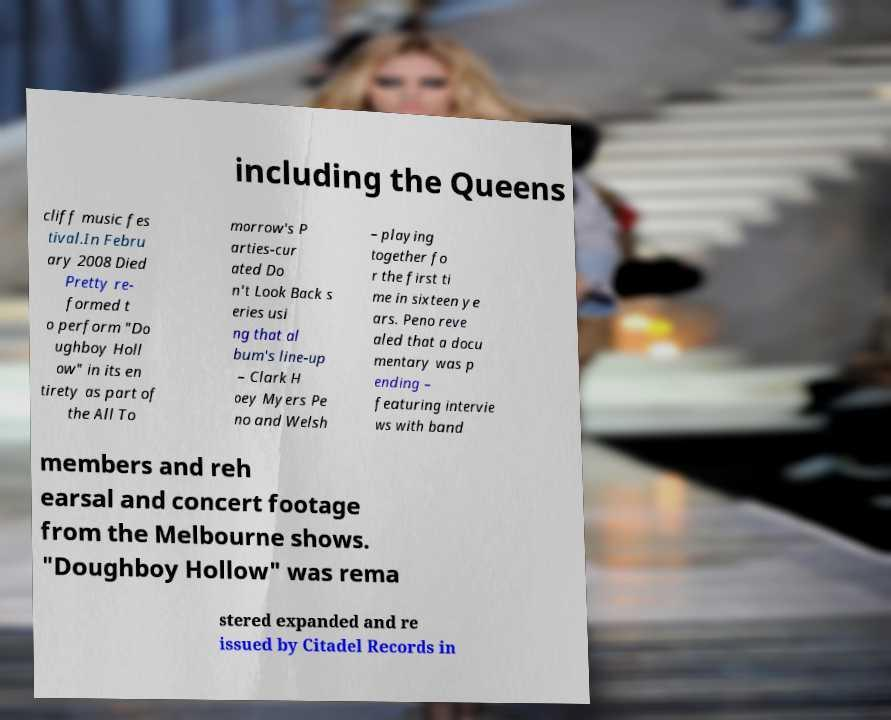I need the written content from this picture converted into text. Can you do that? including the Queens cliff music fes tival.In Febru ary 2008 Died Pretty re- formed t o perform "Do ughboy Holl ow" in its en tirety as part of the All To morrow's P arties-cur ated Do n't Look Back s eries usi ng that al bum's line-up – Clark H oey Myers Pe no and Welsh – playing together fo r the first ti me in sixteen ye ars. Peno reve aled that a docu mentary was p ending – featuring intervie ws with band members and reh earsal and concert footage from the Melbourne shows. "Doughboy Hollow" was rema stered expanded and re issued by Citadel Records in 